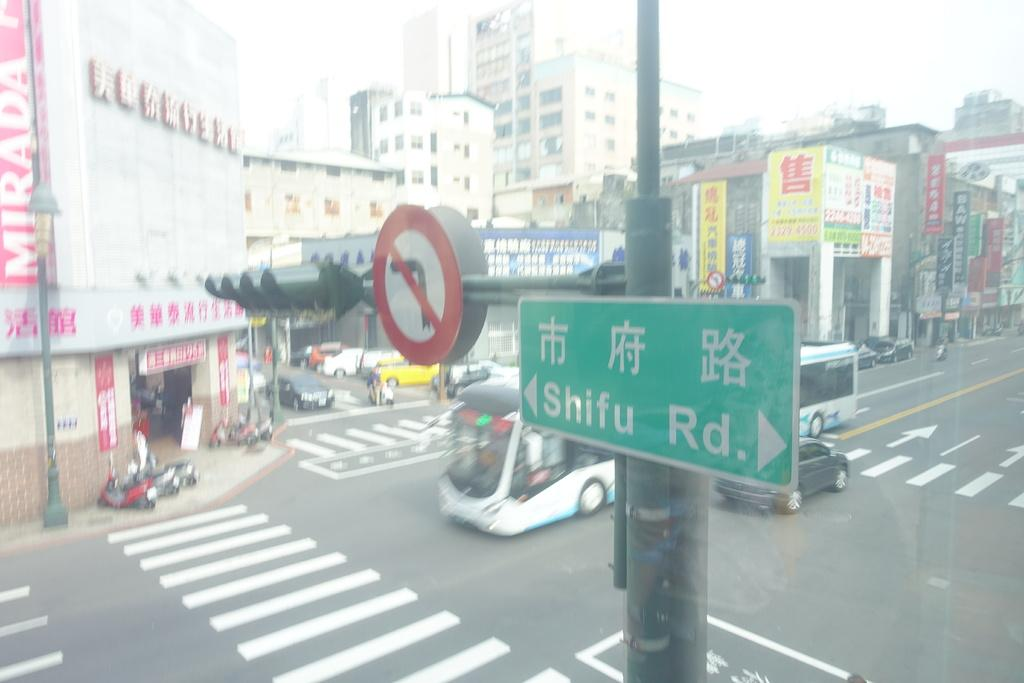<image>
Give a short and clear explanation of the subsequent image. A city full of buildings and streets with traffic and stores and road signs where one says SHIFU  Rd. at an intersection. 